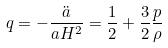Convert formula to latex. <formula><loc_0><loc_0><loc_500><loc_500>q = - \frac { \ddot { a } } { a H ^ { 2 } } = \frac { 1 } { 2 } + \frac { 3 } { 2 } \frac { p } { \rho }</formula> 